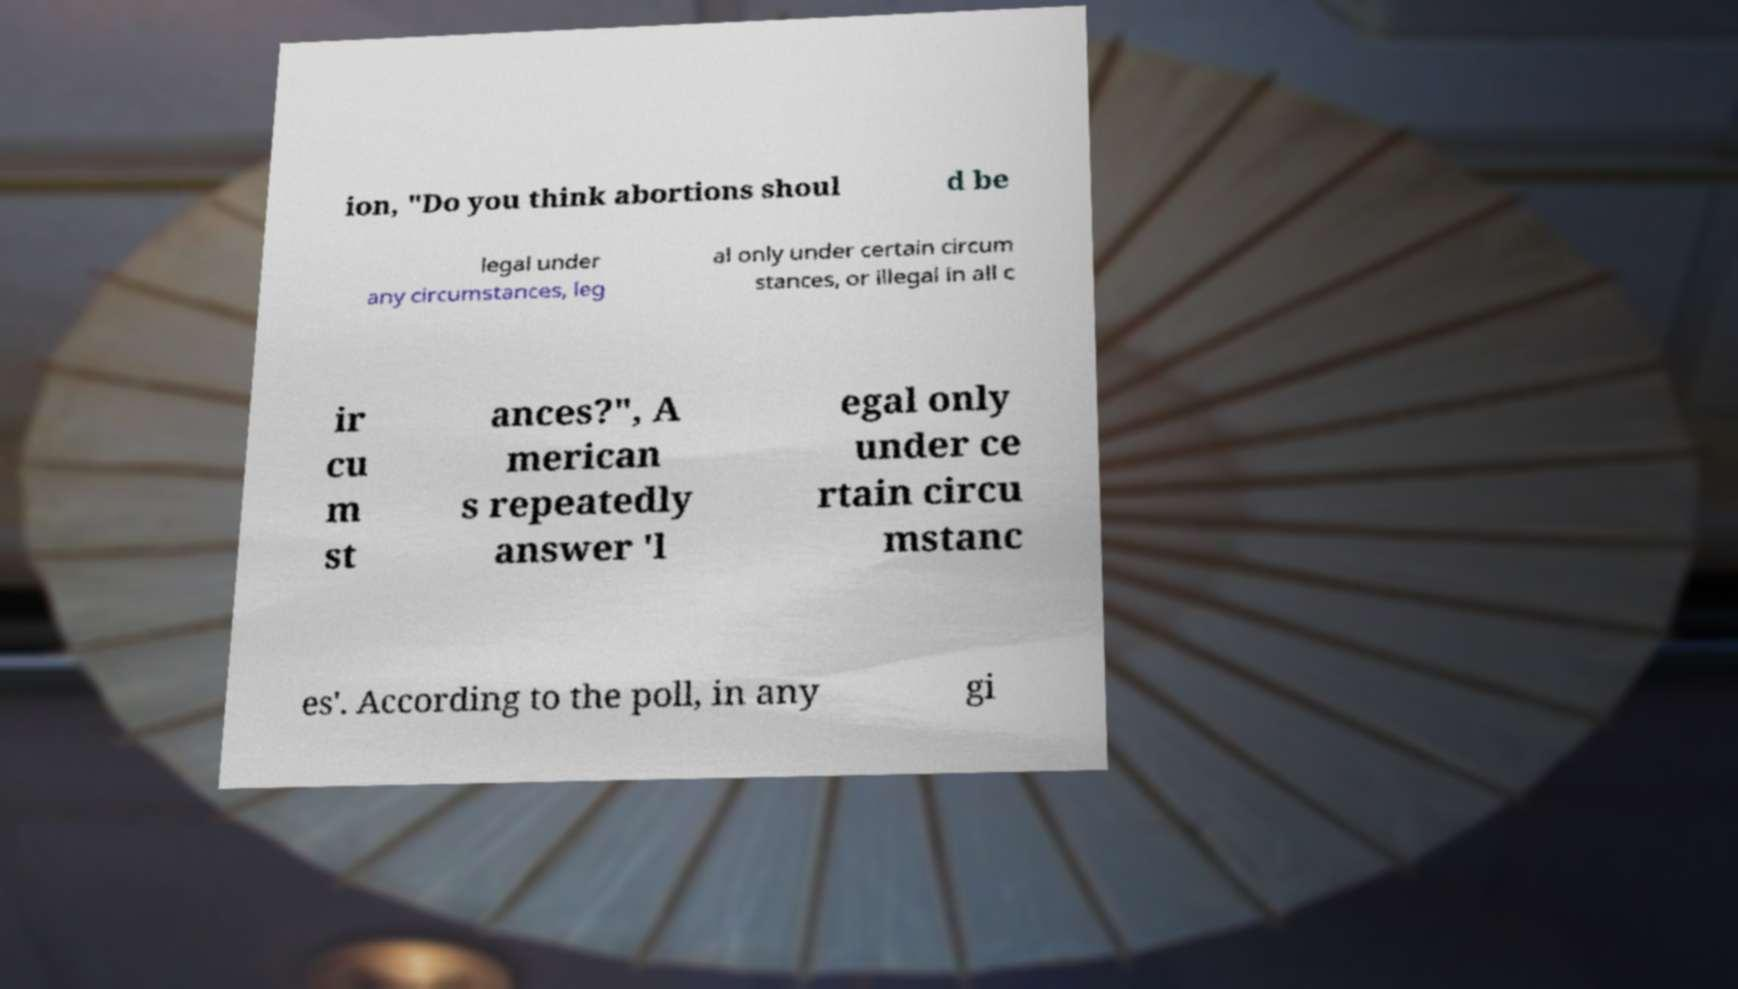Can you read and provide the text displayed in the image?This photo seems to have some interesting text. Can you extract and type it out for me? ion, "Do you think abortions shoul d be legal under any circumstances, leg al only under certain circum stances, or illegal in all c ir cu m st ances?", A merican s repeatedly answer 'l egal only under ce rtain circu mstanc es'. According to the poll, in any gi 